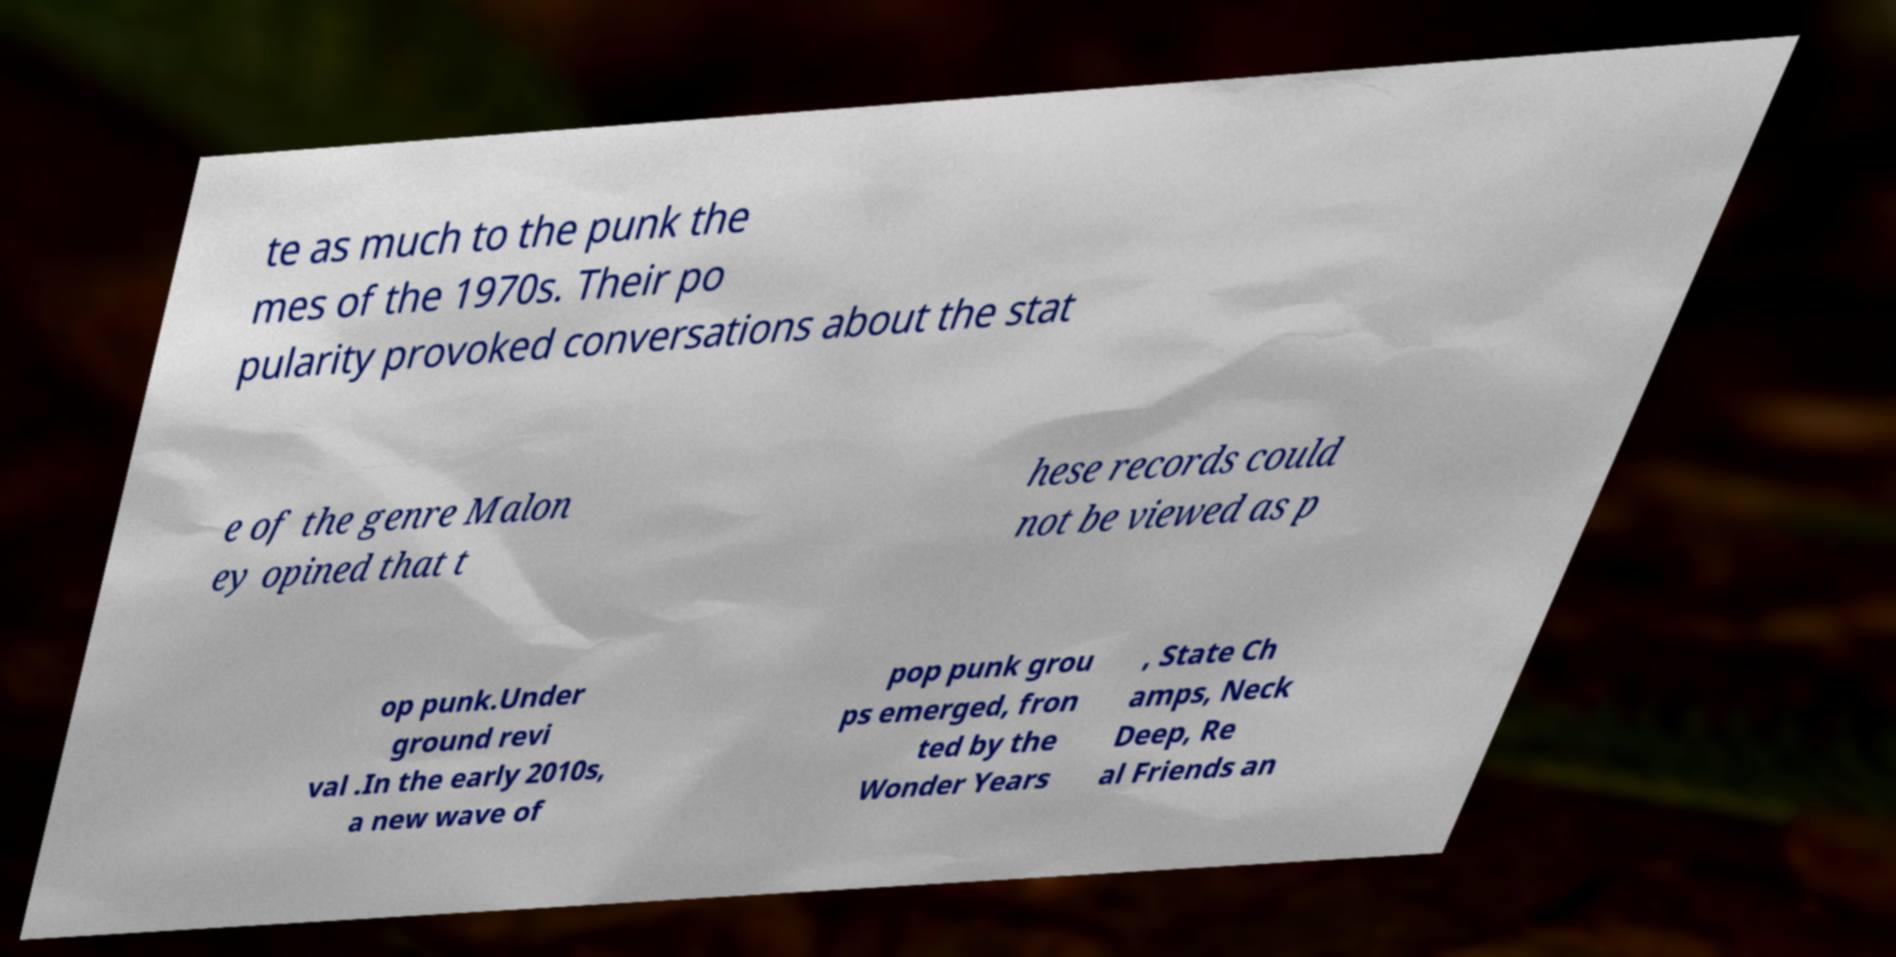I need the written content from this picture converted into text. Can you do that? te as much to the punk the mes of the 1970s. Their po pularity provoked conversations about the stat e of the genre Malon ey opined that t hese records could not be viewed as p op punk.Under ground revi val .In the early 2010s, a new wave of pop punk grou ps emerged, fron ted by the Wonder Years , State Ch amps, Neck Deep, Re al Friends an 